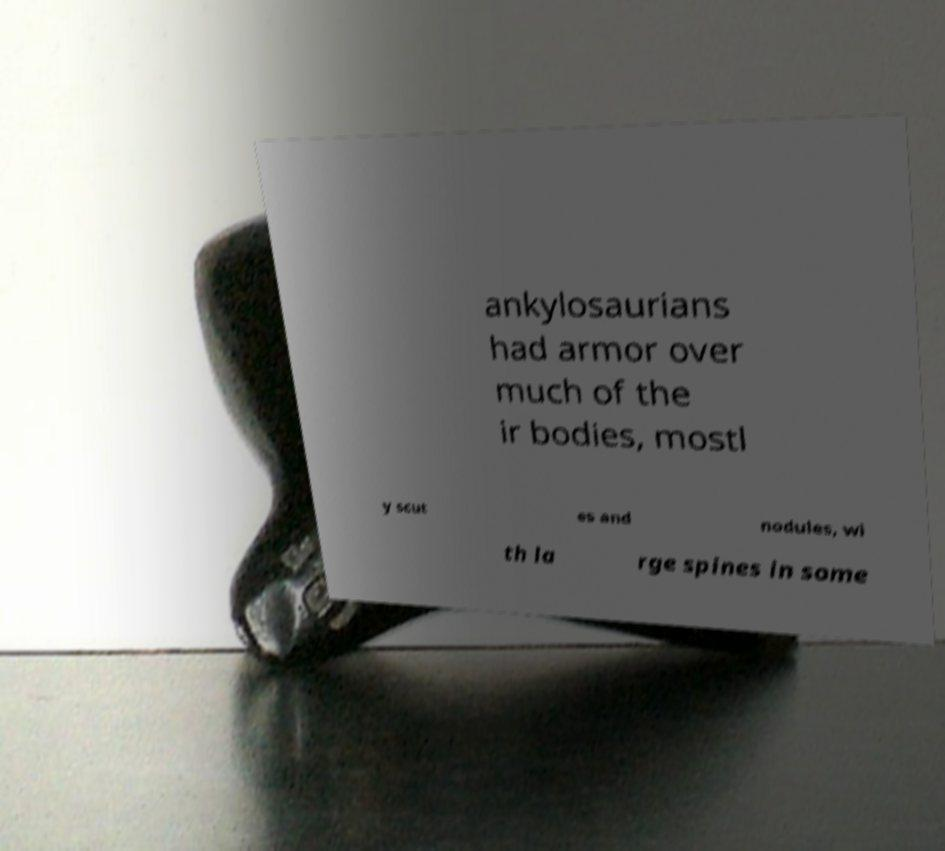Can you accurately transcribe the text from the provided image for me? ankylosaurians had armor over much of the ir bodies, mostl y scut es and nodules, wi th la rge spines in some 